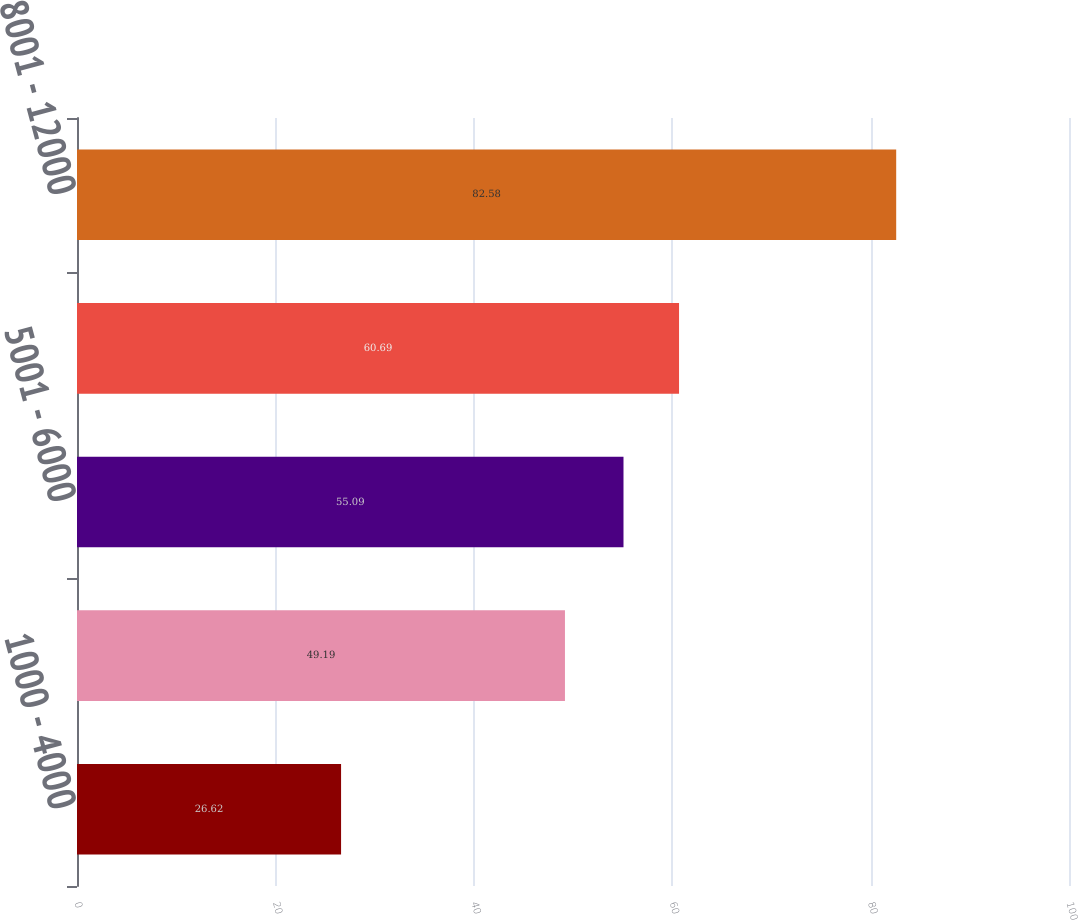<chart> <loc_0><loc_0><loc_500><loc_500><bar_chart><fcel>1000 - 4000<fcel>4001 - 5000<fcel>5001 - 6000<fcel>6001 - 8000<fcel>8001 - 12000<nl><fcel>26.62<fcel>49.19<fcel>55.09<fcel>60.69<fcel>82.58<nl></chart> 